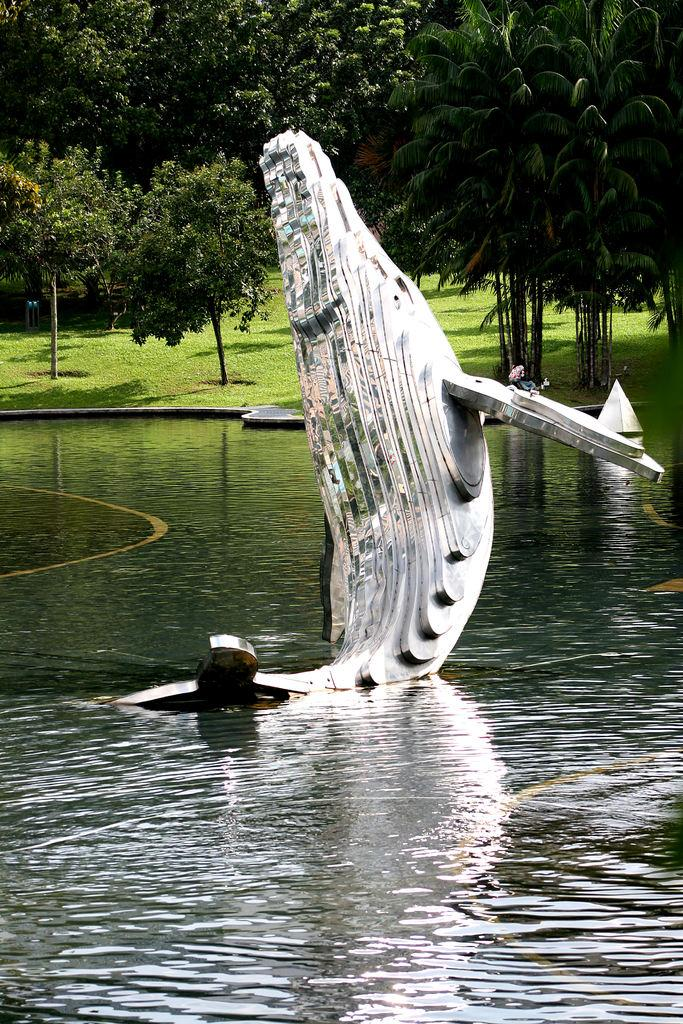What is in the front of the image? There is water in the front of the image. What is on the water? There is a sculpture on the water. What type of vegetation can be seen in the background of the image? There are trees in the background of the image. What else is visible in the background of the image? There is grass visible in the background of the image. Can you see a guitar being played by someone in the image? There is no guitar or person playing a guitar present in the image. What rule is being enforced by the passenger in the image? There is no passenger or rule enforcement present in the image. 